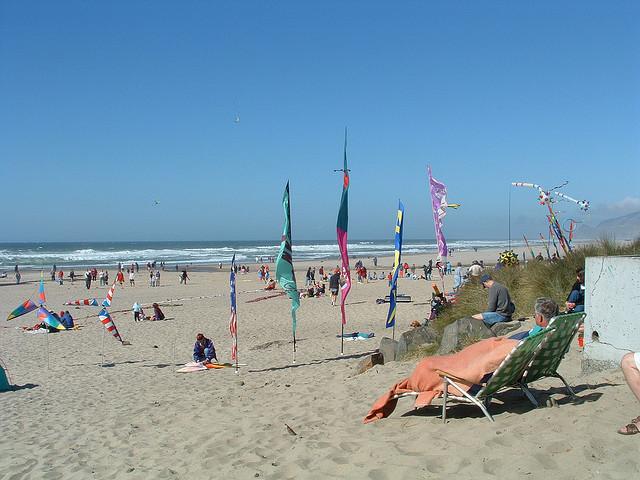Are there kites?
Concise answer only. Yes. What is the brown land surface made of?
Concise answer only. Sand. Is the woman wearing pants underneath her bathing suit?
Give a very brief answer. No. Is this outdoors?
Concise answer only. Yes. 